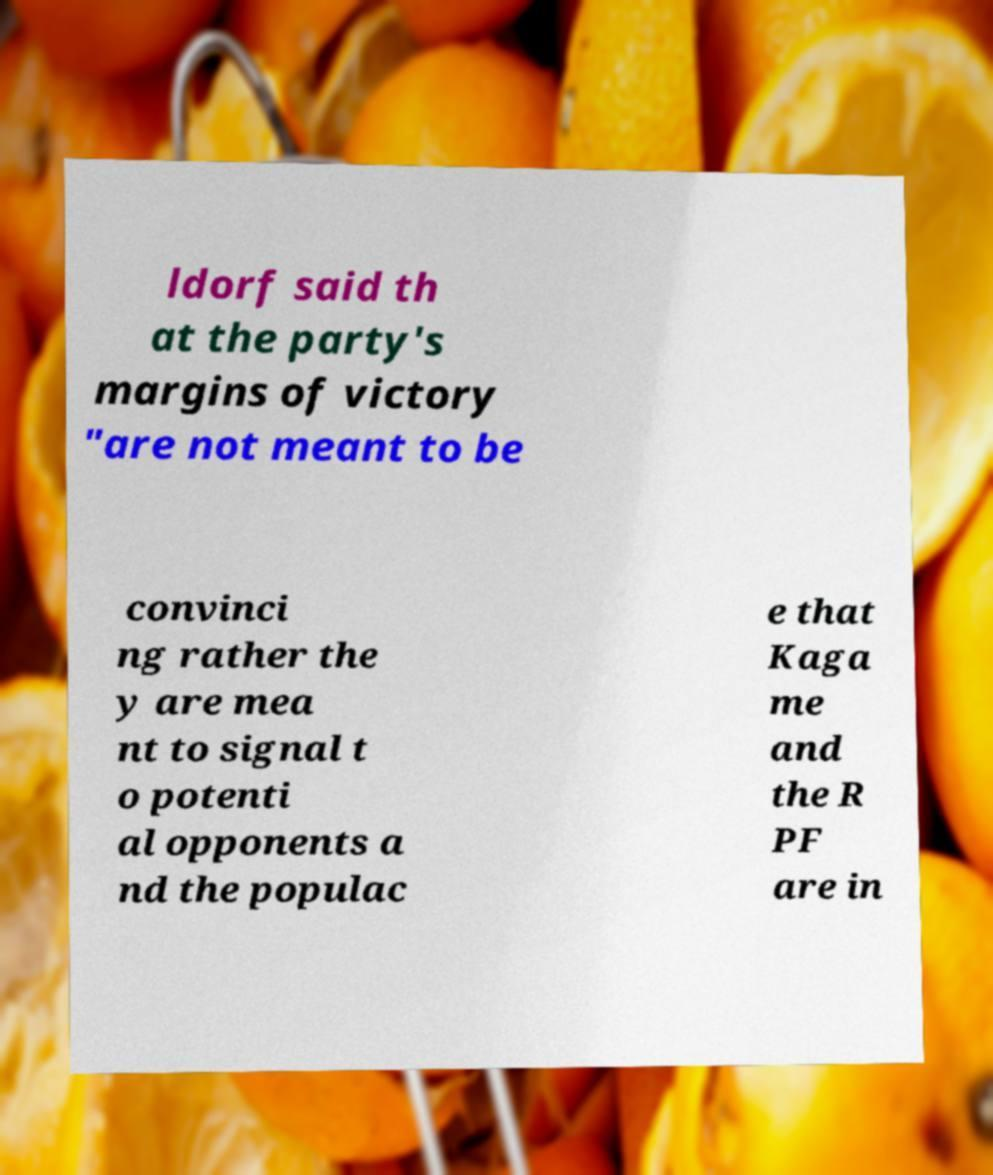Please identify and transcribe the text found in this image. ldorf said th at the party's margins of victory "are not meant to be convinci ng rather the y are mea nt to signal t o potenti al opponents a nd the populac e that Kaga me and the R PF are in 